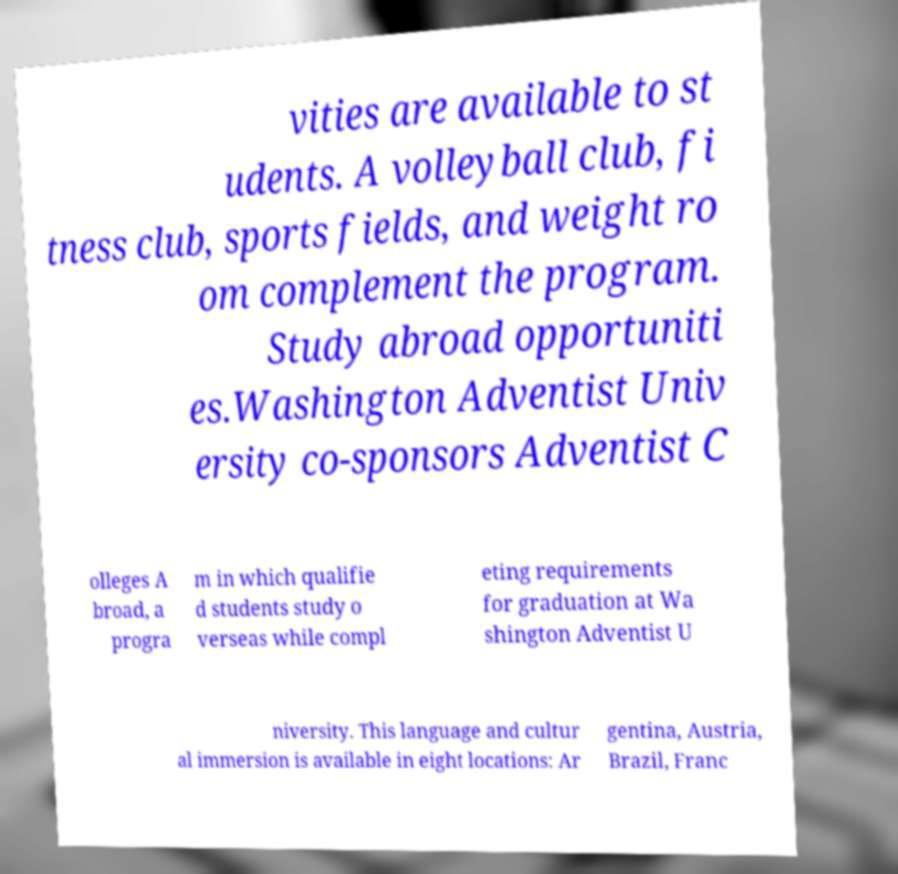What messages or text are displayed in this image? I need them in a readable, typed format. vities are available to st udents. A volleyball club, fi tness club, sports fields, and weight ro om complement the program. Study abroad opportuniti es.Washington Adventist Univ ersity co-sponsors Adventist C olleges A broad, a progra m in which qualifie d students study o verseas while compl eting requirements for graduation at Wa shington Adventist U niversity. This language and cultur al immersion is available in eight locations: Ar gentina, Austria, Brazil, Franc 